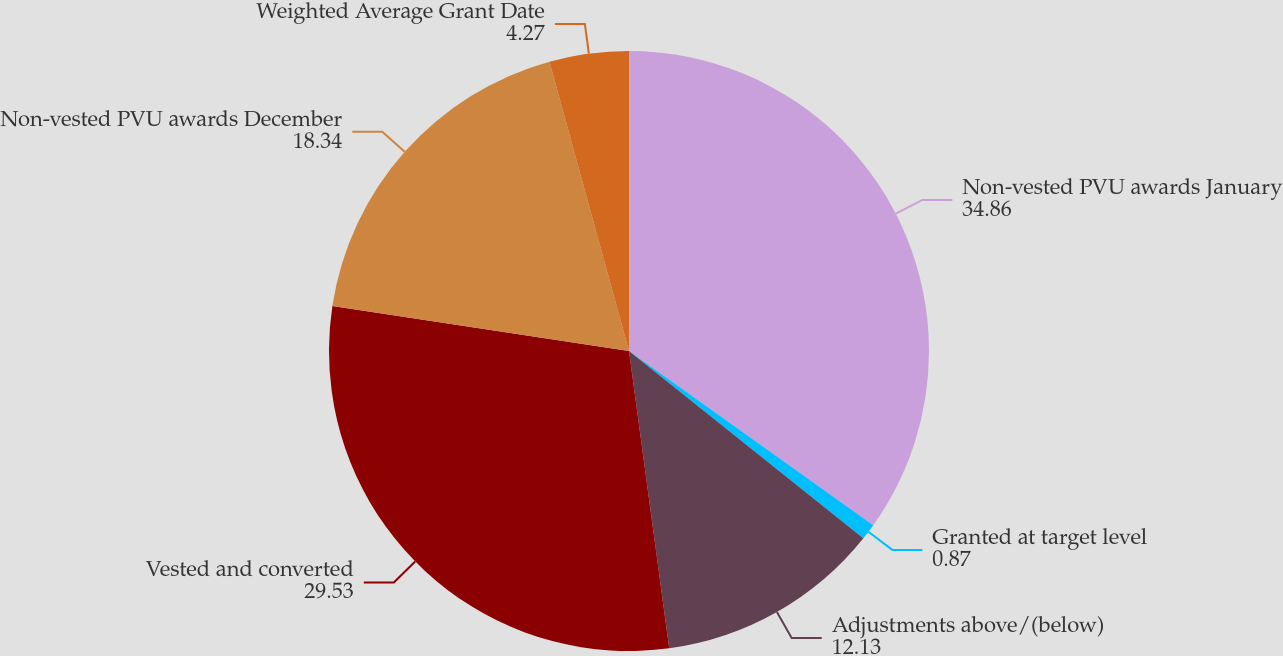Convert chart to OTSL. <chart><loc_0><loc_0><loc_500><loc_500><pie_chart><fcel>Non-vested PVU awards January<fcel>Granted at target level<fcel>Adjustments above/(below)<fcel>Vested and converted<fcel>Non-vested PVU awards December<fcel>Weighted Average Grant Date<nl><fcel>34.86%<fcel>0.87%<fcel>12.13%<fcel>29.53%<fcel>18.34%<fcel>4.27%<nl></chart> 